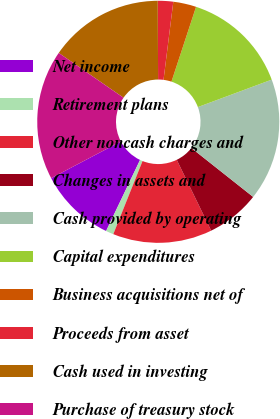Convert chart to OTSL. <chart><loc_0><loc_0><loc_500><loc_500><pie_chart><fcel>Net income<fcel>Retirement plans<fcel>Other noncash charges and<fcel>Changes in assets and<fcel>Cash provided by operating<fcel>Capital expenditures<fcel>Business acquisitions net of<fcel>Proceeds from asset<fcel>Cash used in investing<fcel>Purchase of treasury stock<nl><fcel>10.2%<fcel>1.03%<fcel>13.26%<fcel>7.14%<fcel>16.32%<fcel>14.28%<fcel>3.07%<fcel>2.05%<fcel>15.3%<fcel>17.34%<nl></chart> 